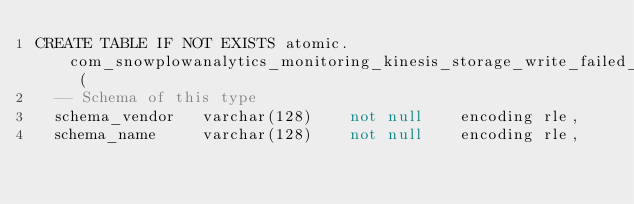Convert code to text. <code><loc_0><loc_0><loc_500><loc_500><_SQL_>CREATE TABLE IF NOT EXISTS atomic.com_snowplowanalytics_monitoring_kinesis_storage_write_failed_1 (
	-- Schema of this type
	schema_vendor		varchar(128)		not null		encoding rle,
	schema_name 		varchar(128)		not null		encoding rle,</code> 